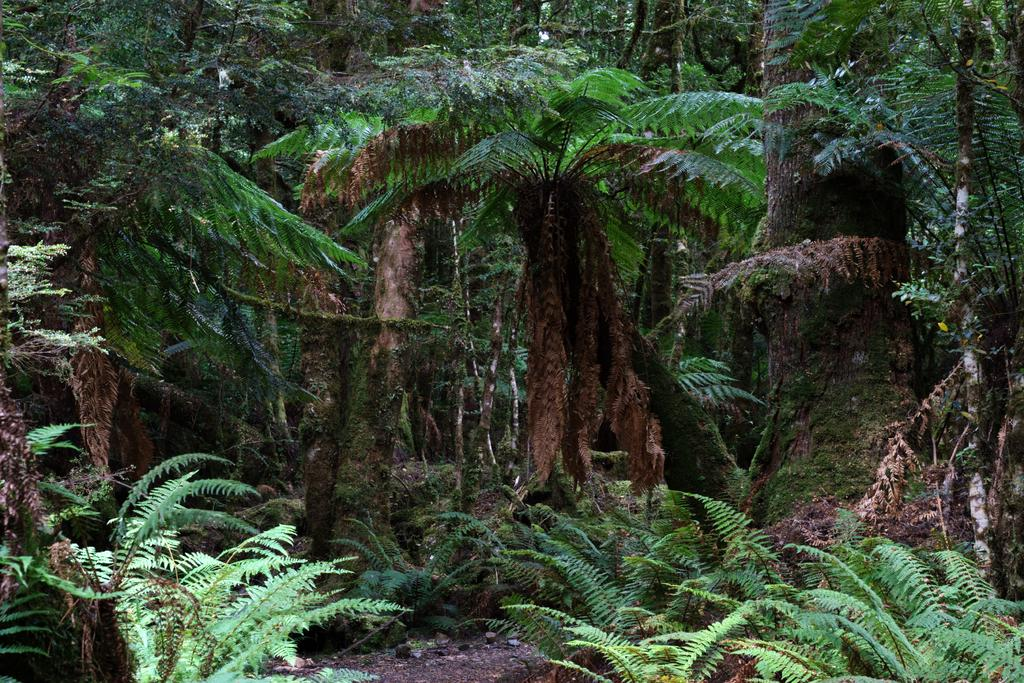Where was the picture taken? The picture was clicked outside. What can be seen in the foreground of the image? There are plants in the foreground of the image. What can be seen in the background of the image? There are trees and other objects visible in the background of the image. What type of vest is the tree wearing in the image? There is no vest present in the image, as trees do not wear clothing. 